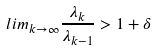<formula> <loc_0><loc_0><loc_500><loc_500>l i m _ { k \rightarrow \infty } \frac { \lambda _ { k } } { \lambda _ { k - 1 } } > 1 + \delta</formula> 